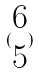Convert formula to latex. <formula><loc_0><loc_0><loc_500><loc_500>( \begin{matrix} 6 \\ 5 \end{matrix} )</formula> 